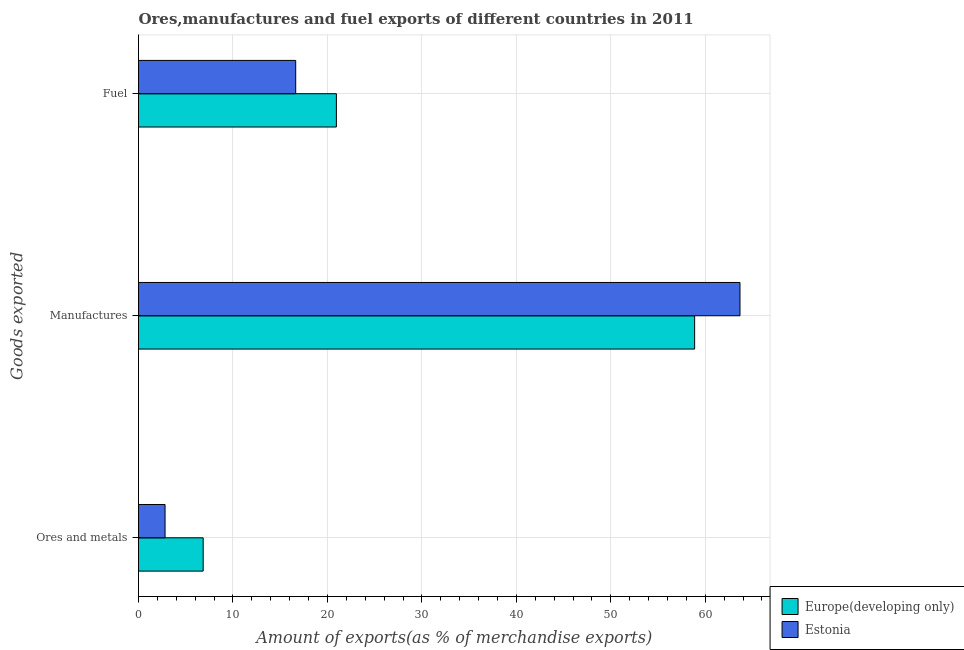How many different coloured bars are there?
Offer a terse response. 2. Are the number of bars per tick equal to the number of legend labels?
Keep it short and to the point. Yes. Are the number of bars on each tick of the Y-axis equal?
Ensure brevity in your answer.  Yes. What is the label of the 2nd group of bars from the top?
Ensure brevity in your answer.  Manufactures. What is the percentage of manufactures exports in Europe(developing only)?
Give a very brief answer. 58.87. Across all countries, what is the maximum percentage of ores and metals exports?
Ensure brevity in your answer.  6.85. Across all countries, what is the minimum percentage of ores and metals exports?
Give a very brief answer. 2.81. In which country was the percentage of fuel exports maximum?
Make the answer very short. Europe(developing only). In which country was the percentage of manufactures exports minimum?
Give a very brief answer. Europe(developing only). What is the total percentage of manufactures exports in the graph?
Make the answer very short. 122.55. What is the difference between the percentage of ores and metals exports in Europe(developing only) and that in Estonia?
Give a very brief answer. 4.04. What is the difference between the percentage of manufactures exports in Europe(developing only) and the percentage of fuel exports in Estonia?
Your answer should be compact. 42.23. What is the average percentage of ores and metals exports per country?
Your response must be concise. 4.83. What is the difference between the percentage of manufactures exports and percentage of ores and metals exports in Europe(developing only)?
Provide a short and direct response. 52.03. In how many countries, is the percentage of manufactures exports greater than 20 %?
Ensure brevity in your answer.  2. What is the ratio of the percentage of ores and metals exports in Europe(developing only) to that in Estonia?
Keep it short and to the point. 2.44. Is the percentage of manufactures exports in Estonia less than that in Europe(developing only)?
Your answer should be very brief. No. Is the difference between the percentage of manufactures exports in Estonia and Europe(developing only) greater than the difference between the percentage of ores and metals exports in Estonia and Europe(developing only)?
Offer a terse response. Yes. What is the difference between the highest and the second highest percentage of fuel exports?
Provide a succinct answer. 4.31. What is the difference between the highest and the lowest percentage of ores and metals exports?
Keep it short and to the point. 4.04. In how many countries, is the percentage of ores and metals exports greater than the average percentage of ores and metals exports taken over all countries?
Give a very brief answer. 1. Is the sum of the percentage of fuel exports in Europe(developing only) and Estonia greater than the maximum percentage of manufactures exports across all countries?
Provide a short and direct response. No. What does the 1st bar from the top in Manufactures represents?
Give a very brief answer. Estonia. What does the 1st bar from the bottom in Ores and metals represents?
Ensure brevity in your answer.  Europe(developing only). Is it the case that in every country, the sum of the percentage of ores and metals exports and percentage of manufactures exports is greater than the percentage of fuel exports?
Provide a succinct answer. Yes. Are all the bars in the graph horizontal?
Your response must be concise. Yes. How many countries are there in the graph?
Offer a very short reply. 2. What is the difference between two consecutive major ticks on the X-axis?
Keep it short and to the point. 10. Are the values on the major ticks of X-axis written in scientific E-notation?
Ensure brevity in your answer.  No. Does the graph contain grids?
Your answer should be very brief. Yes. Where does the legend appear in the graph?
Your answer should be compact. Bottom right. How many legend labels are there?
Give a very brief answer. 2. How are the legend labels stacked?
Ensure brevity in your answer.  Vertical. What is the title of the graph?
Keep it short and to the point. Ores,manufactures and fuel exports of different countries in 2011. Does "East Asia (developing only)" appear as one of the legend labels in the graph?
Keep it short and to the point. No. What is the label or title of the X-axis?
Your answer should be very brief. Amount of exports(as % of merchandise exports). What is the label or title of the Y-axis?
Make the answer very short. Goods exported. What is the Amount of exports(as % of merchandise exports) of Europe(developing only) in Ores and metals?
Provide a succinct answer. 6.85. What is the Amount of exports(as % of merchandise exports) of Estonia in Ores and metals?
Your answer should be compact. 2.81. What is the Amount of exports(as % of merchandise exports) of Europe(developing only) in Manufactures?
Offer a very short reply. 58.87. What is the Amount of exports(as % of merchandise exports) of Estonia in Manufactures?
Provide a short and direct response. 63.67. What is the Amount of exports(as % of merchandise exports) in Europe(developing only) in Fuel?
Give a very brief answer. 20.95. What is the Amount of exports(as % of merchandise exports) in Estonia in Fuel?
Make the answer very short. 16.64. Across all Goods exported, what is the maximum Amount of exports(as % of merchandise exports) of Europe(developing only)?
Your answer should be very brief. 58.87. Across all Goods exported, what is the maximum Amount of exports(as % of merchandise exports) in Estonia?
Offer a terse response. 63.67. Across all Goods exported, what is the minimum Amount of exports(as % of merchandise exports) of Europe(developing only)?
Ensure brevity in your answer.  6.85. Across all Goods exported, what is the minimum Amount of exports(as % of merchandise exports) of Estonia?
Provide a succinct answer. 2.81. What is the total Amount of exports(as % of merchandise exports) in Europe(developing only) in the graph?
Your answer should be very brief. 86.67. What is the total Amount of exports(as % of merchandise exports) in Estonia in the graph?
Offer a very short reply. 83.12. What is the difference between the Amount of exports(as % of merchandise exports) of Europe(developing only) in Ores and metals and that in Manufactures?
Offer a terse response. -52.03. What is the difference between the Amount of exports(as % of merchandise exports) of Estonia in Ores and metals and that in Manufactures?
Keep it short and to the point. -60.86. What is the difference between the Amount of exports(as % of merchandise exports) of Europe(developing only) in Ores and metals and that in Fuel?
Your answer should be compact. -14.1. What is the difference between the Amount of exports(as % of merchandise exports) of Estonia in Ores and metals and that in Fuel?
Make the answer very short. -13.83. What is the difference between the Amount of exports(as % of merchandise exports) of Europe(developing only) in Manufactures and that in Fuel?
Your response must be concise. 37.92. What is the difference between the Amount of exports(as % of merchandise exports) of Estonia in Manufactures and that in Fuel?
Your answer should be compact. 47.03. What is the difference between the Amount of exports(as % of merchandise exports) in Europe(developing only) in Ores and metals and the Amount of exports(as % of merchandise exports) in Estonia in Manufactures?
Offer a terse response. -56.83. What is the difference between the Amount of exports(as % of merchandise exports) of Europe(developing only) in Ores and metals and the Amount of exports(as % of merchandise exports) of Estonia in Fuel?
Make the answer very short. -9.79. What is the difference between the Amount of exports(as % of merchandise exports) in Europe(developing only) in Manufactures and the Amount of exports(as % of merchandise exports) in Estonia in Fuel?
Your response must be concise. 42.23. What is the average Amount of exports(as % of merchandise exports) in Europe(developing only) per Goods exported?
Offer a very short reply. 28.89. What is the average Amount of exports(as % of merchandise exports) in Estonia per Goods exported?
Provide a short and direct response. 27.71. What is the difference between the Amount of exports(as % of merchandise exports) in Europe(developing only) and Amount of exports(as % of merchandise exports) in Estonia in Ores and metals?
Your answer should be compact. 4.04. What is the difference between the Amount of exports(as % of merchandise exports) of Europe(developing only) and Amount of exports(as % of merchandise exports) of Estonia in Manufactures?
Ensure brevity in your answer.  -4.8. What is the difference between the Amount of exports(as % of merchandise exports) of Europe(developing only) and Amount of exports(as % of merchandise exports) of Estonia in Fuel?
Your response must be concise. 4.31. What is the ratio of the Amount of exports(as % of merchandise exports) of Europe(developing only) in Ores and metals to that in Manufactures?
Keep it short and to the point. 0.12. What is the ratio of the Amount of exports(as % of merchandise exports) of Estonia in Ores and metals to that in Manufactures?
Make the answer very short. 0.04. What is the ratio of the Amount of exports(as % of merchandise exports) in Europe(developing only) in Ores and metals to that in Fuel?
Make the answer very short. 0.33. What is the ratio of the Amount of exports(as % of merchandise exports) in Estonia in Ores and metals to that in Fuel?
Offer a very short reply. 0.17. What is the ratio of the Amount of exports(as % of merchandise exports) in Europe(developing only) in Manufactures to that in Fuel?
Offer a very short reply. 2.81. What is the ratio of the Amount of exports(as % of merchandise exports) in Estonia in Manufactures to that in Fuel?
Ensure brevity in your answer.  3.83. What is the difference between the highest and the second highest Amount of exports(as % of merchandise exports) of Europe(developing only)?
Your answer should be very brief. 37.92. What is the difference between the highest and the second highest Amount of exports(as % of merchandise exports) in Estonia?
Give a very brief answer. 47.03. What is the difference between the highest and the lowest Amount of exports(as % of merchandise exports) of Europe(developing only)?
Ensure brevity in your answer.  52.03. What is the difference between the highest and the lowest Amount of exports(as % of merchandise exports) of Estonia?
Provide a succinct answer. 60.86. 